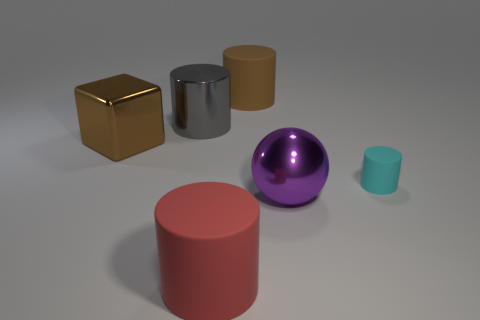Add 2 brown metal things. How many objects exist? 8 Subtract all spheres. How many objects are left? 5 Add 3 big shiny balls. How many big shiny balls are left? 4 Add 5 big brown balls. How many big brown balls exist? 5 Subtract 0 yellow blocks. How many objects are left? 6 Subtract all cyan metal objects. Subtract all large metal cylinders. How many objects are left? 5 